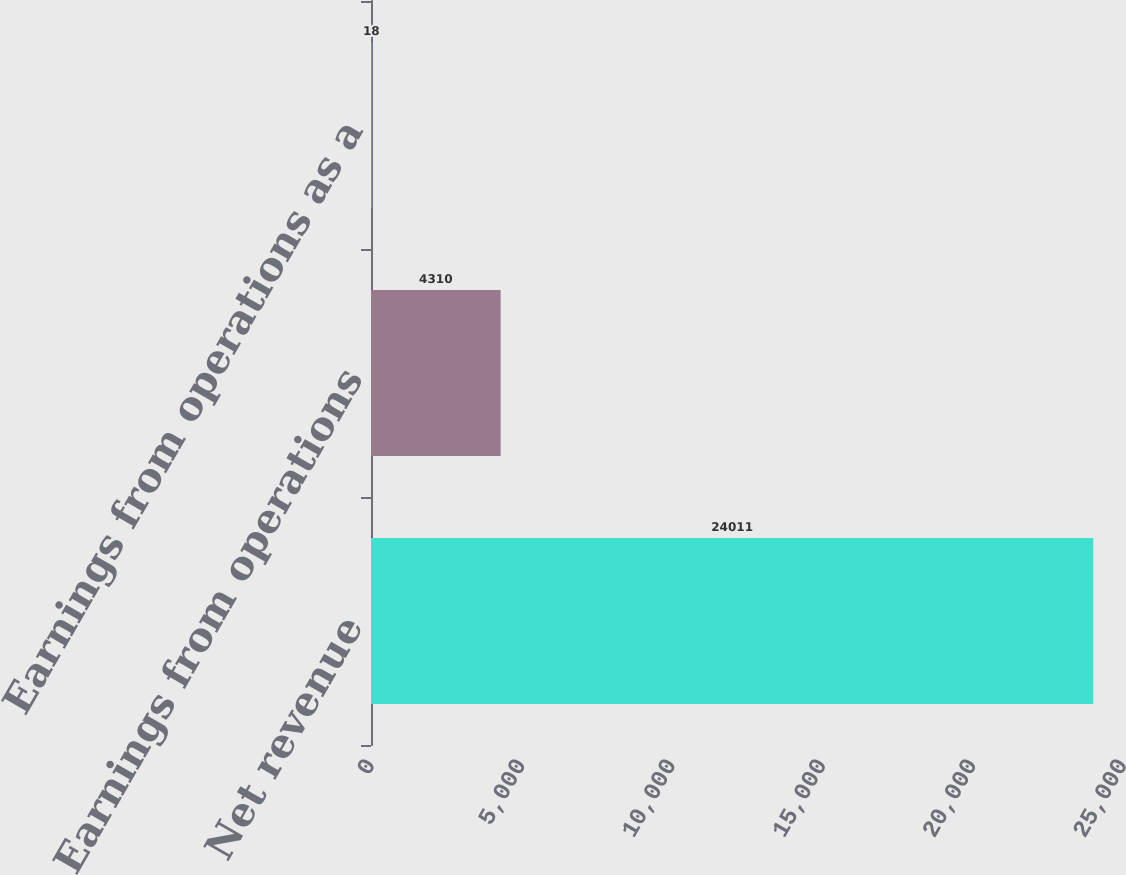Convert chart to OTSL. <chart><loc_0><loc_0><loc_500><loc_500><bar_chart><fcel>Net revenue<fcel>Earnings from operations<fcel>Earnings from operations as a<nl><fcel>24011<fcel>4310<fcel>18<nl></chart> 